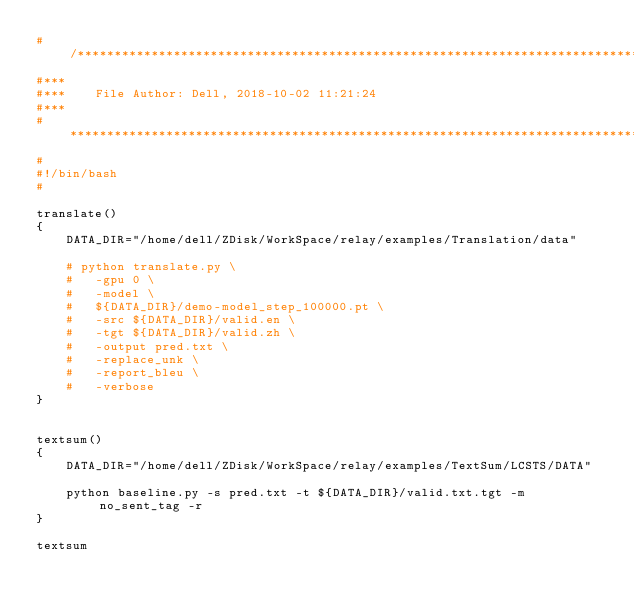Convert code to text. <code><loc_0><loc_0><loc_500><loc_500><_Bash_>#/************************************************************************************
#***
#***	File Author: Dell, 2018-10-02 11:21:24
#***
#************************************************************************************/
#
#!/bin/bash
#

translate()
{
	DATA_DIR="/home/dell/ZDisk/WorkSpace/relay/examples/Translation/data"

	# python translate.py \
	# 	-gpu 0 \
	# 	-model \
	# 	${DATA_DIR}/demo-model_step_100000.pt \
	# 	-src ${DATA_DIR}/valid.en \
	# 	-tgt ${DATA_DIR}/valid.zh \
	# 	-output pred.txt \
	# 	-replace_unk \
	# 	-report_bleu \
	# 	-verbose
}


textsum()
{
	DATA_DIR="/home/dell/ZDisk/WorkSpace/relay/examples/TextSum/LCSTS/DATA"

	python baseline.py -s pred.txt -t ${DATA_DIR}/valid.txt.tgt -m no_sent_tag -r
}

textsum
</code> 